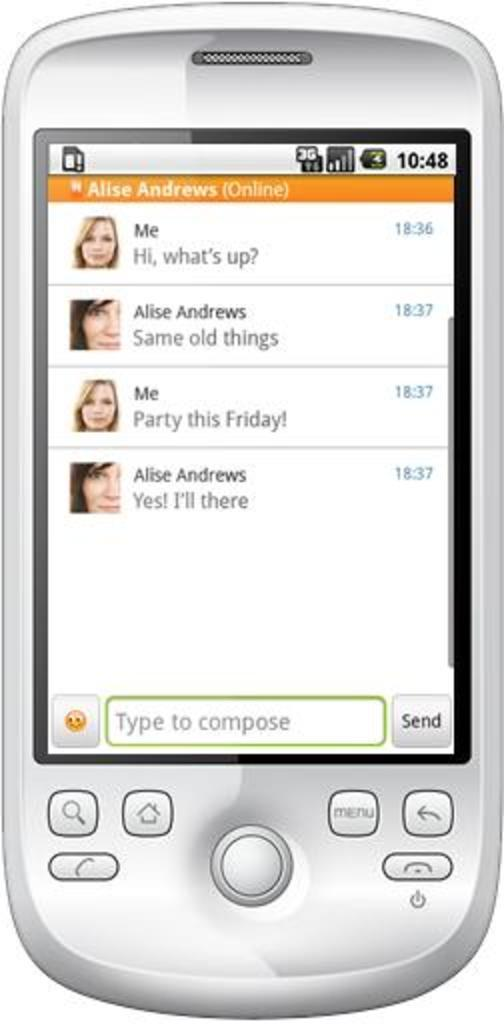Provide a one-sentence caption for the provided image. A phone displaying text messages about a party on the screen. 